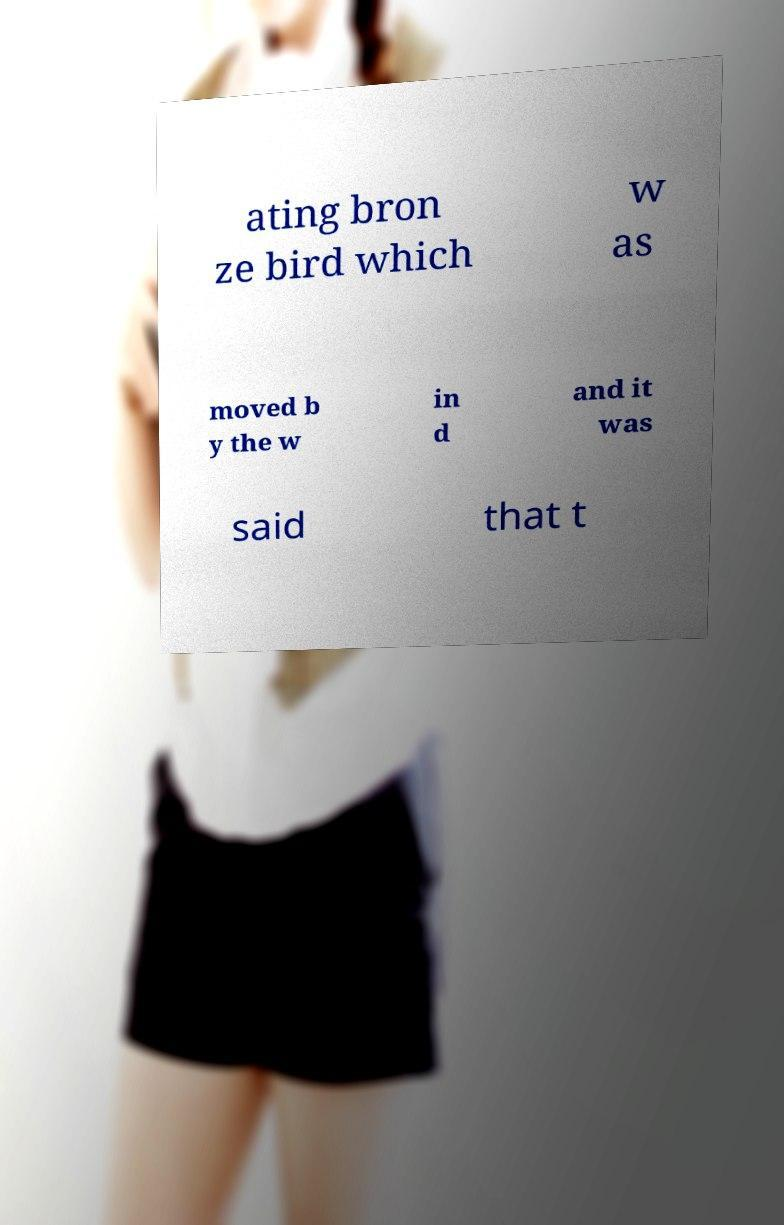Could you assist in decoding the text presented in this image and type it out clearly? ating bron ze bird which w as moved b y the w in d and it was said that t 